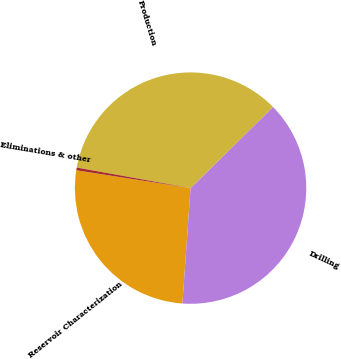<chart> <loc_0><loc_0><loc_500><loc_500><pie_chart><fcel>Reservoir Characterization<fcel>Drilling<fcel>Production<fcel>Eliminations & other<nl><fcel>26.34%<fcel>38.5%<fcel>34.78%<fcel>0.38%<nl></chart> 